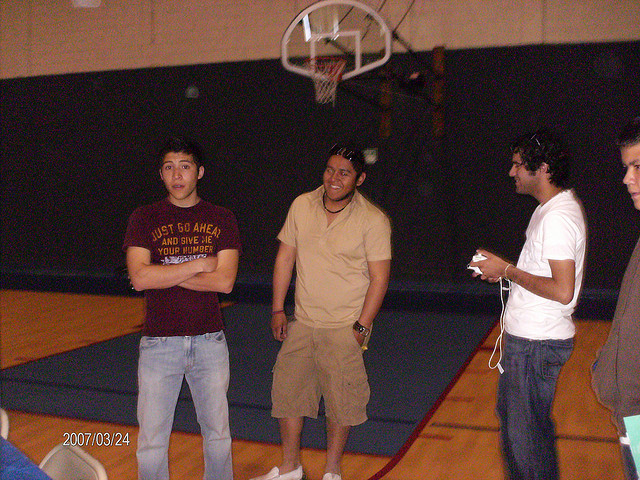What activity are they about to engage in? Based on the setting of a gymnasium and the presence of a basketball hoop in the background, it seems they are either about to play basketball or are taking a break from playing. 